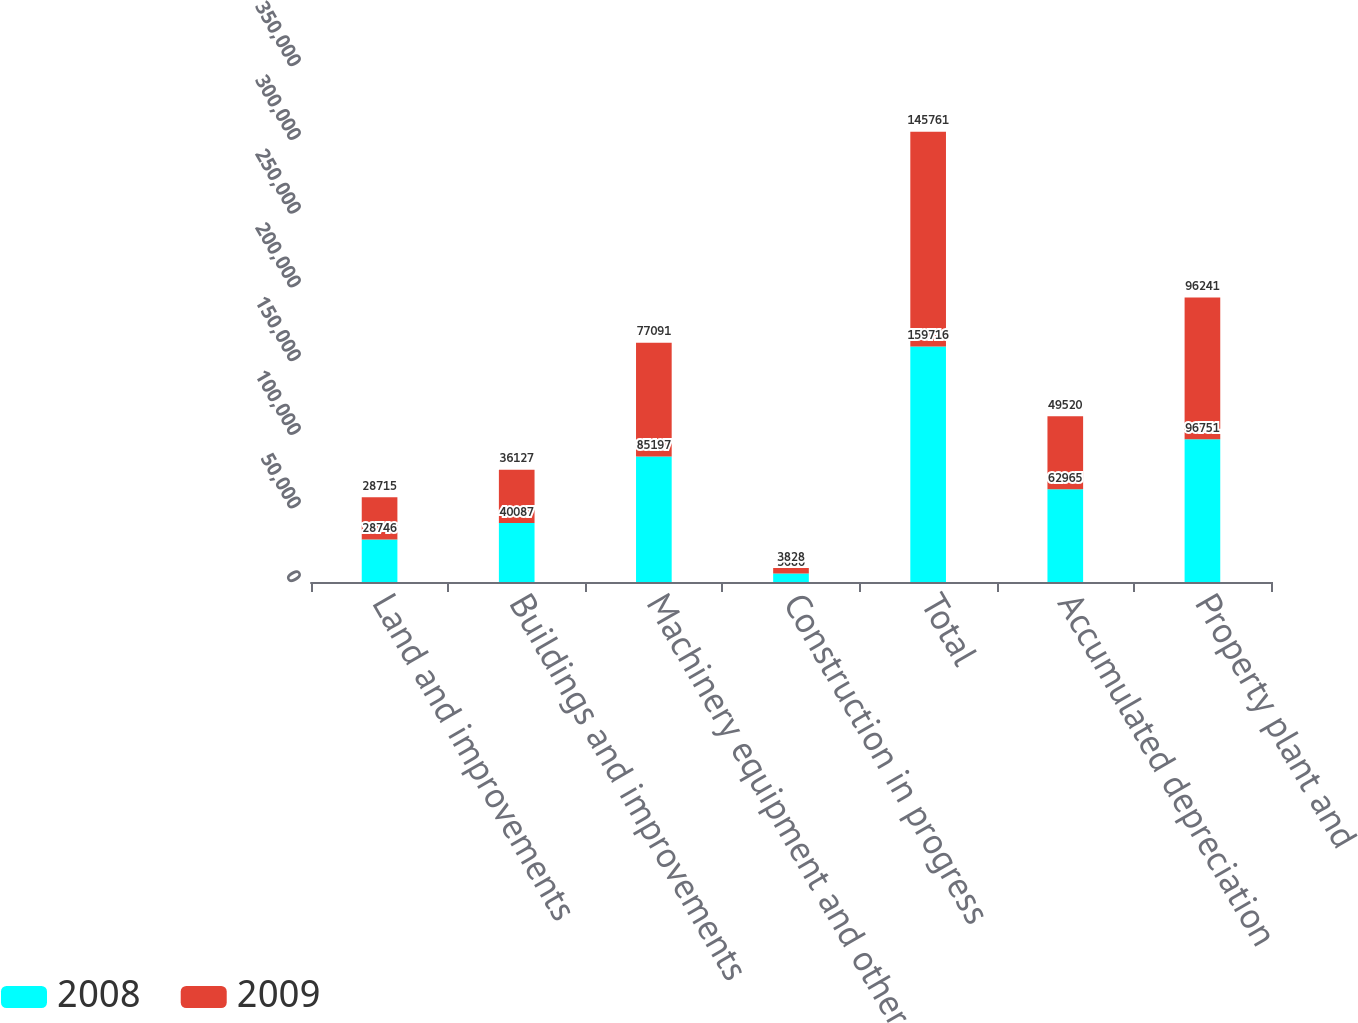<chart> <loc_0><loc_0><loc_500><loc_500><stacked_bar_chart><ecel><fcel>Land and improvements<fcel>Buildings and improvements<fcel>Machinery equipment and other<fcel>Construction in progress<fcel>Total<fcel>Accumulated depreciation<fcel>Property plant and<nl><fcel>2008<fcel>28746<fcel>40087<fcel>85197<fcel>5686<fcel>159716<fcel>62965<fcel>96751<nl><fcel>2009<fcel>28715<fcel>36127<fcel>77091<fcel>3828<fcel>145761<fcel>49520<fcel>96241<nl></chart> 